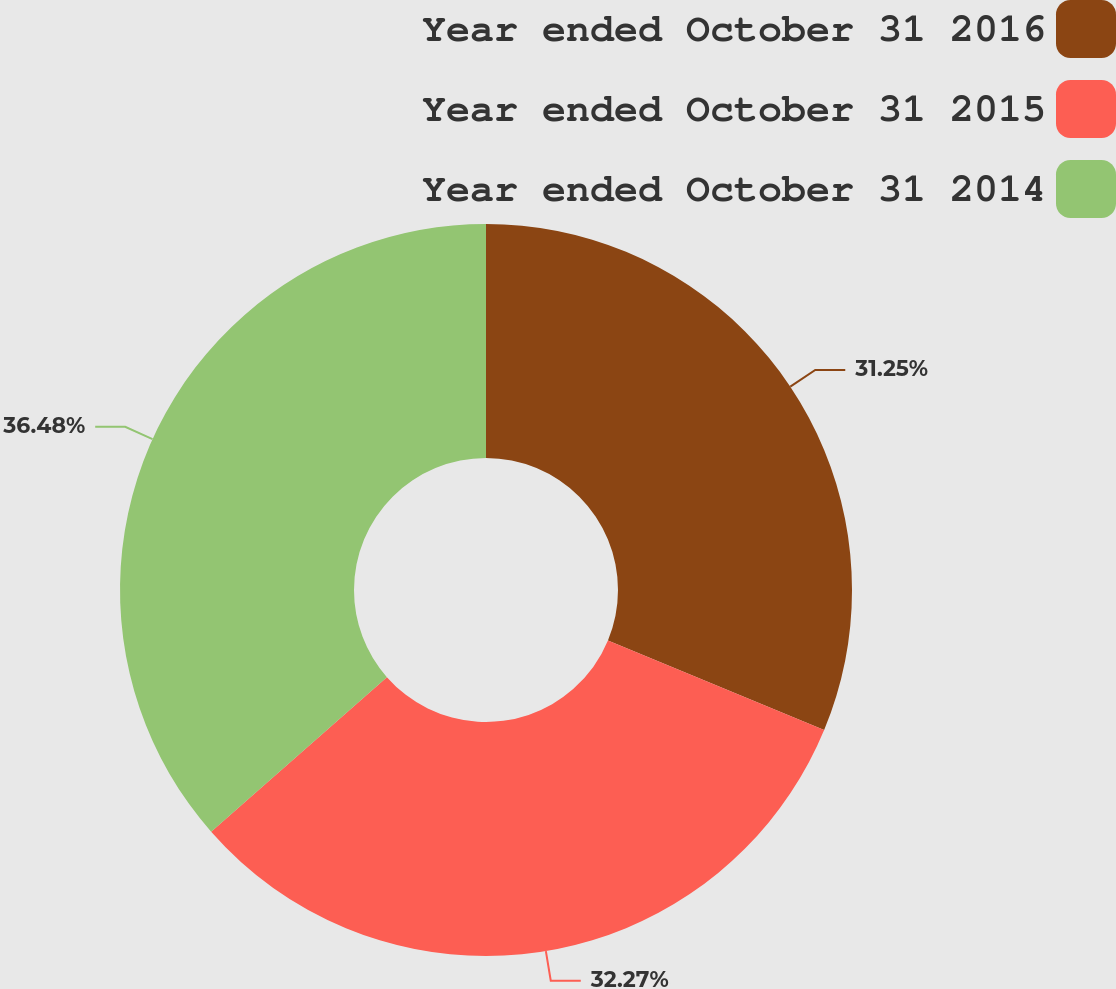<chart> <loc_0><loc_0><loc_500><loc_500><pie_chart><fcel>Year ended October 31 2016<fcel>Year ended October 31 2015<fcel>Year ended October 31 2014<nl><fcel>31.25%<fcel>32.27%<fcel>36.48%<nl></chart> 